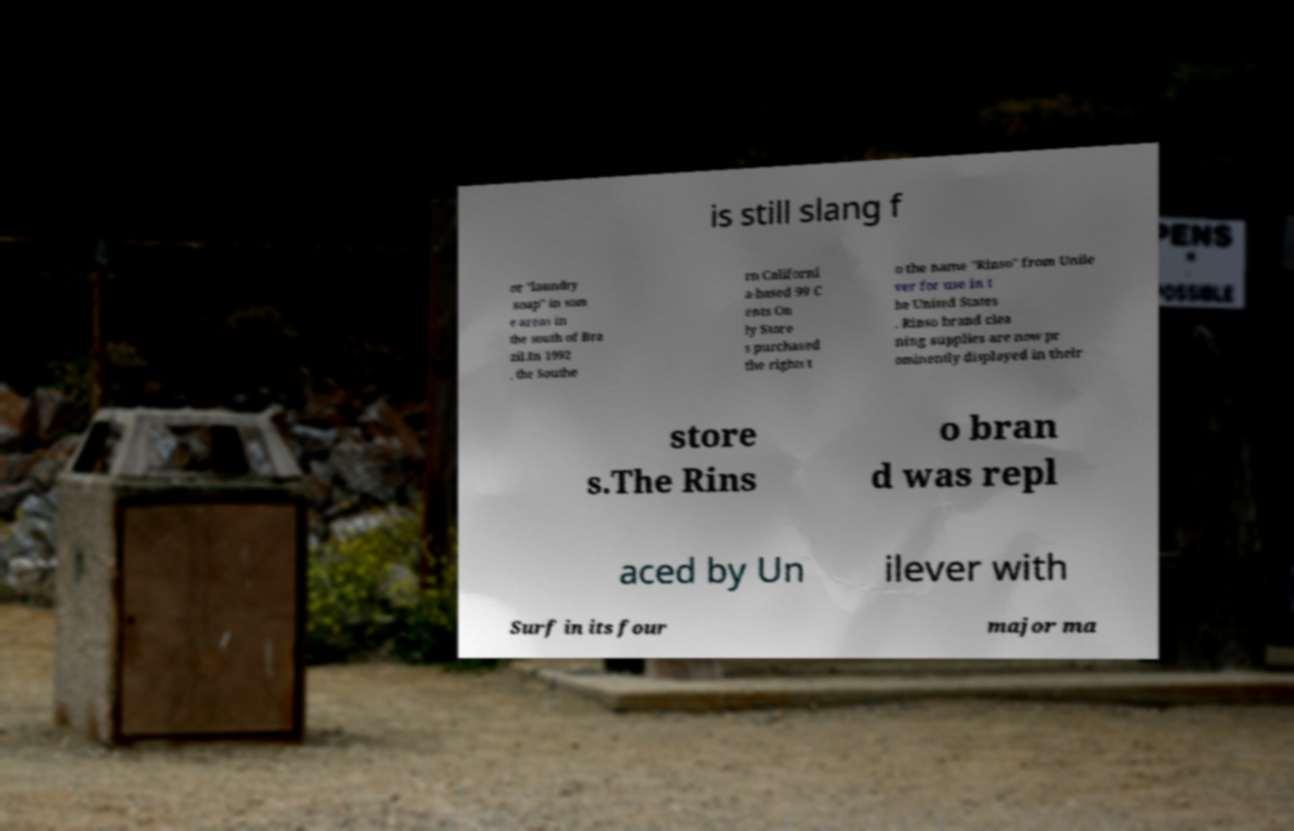Could you assist in decoding the text presented in this image and type it out clearly? is still slang f or "laundry soap" in som e areas in the south of Bra zil.In 1992 , the Southe rn Californi a-based 99 C ents On ly Store s purchased the rights t o the name "Rinso" from Unile ver for use in t he United States . Rinso brand clea ning supplies are now pr ominently displayed in their store s.The Rins o bran d was repl aced by Un ilever with Surf in its four major ma 